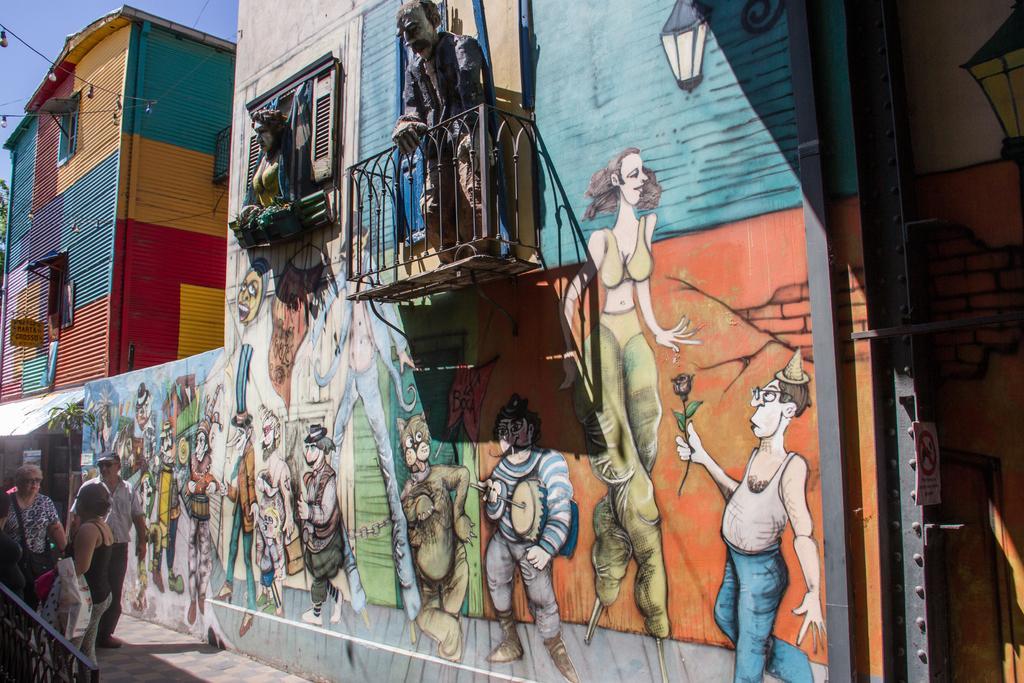How would you summarize this image in a sentence or two? In this image, we can see paintings on wall. Here we can see railing, building, board, sign board and few objects. On the left side bottom corner, we can see people, grille and plant. On the left side top corner there is the sky and bulbs. 